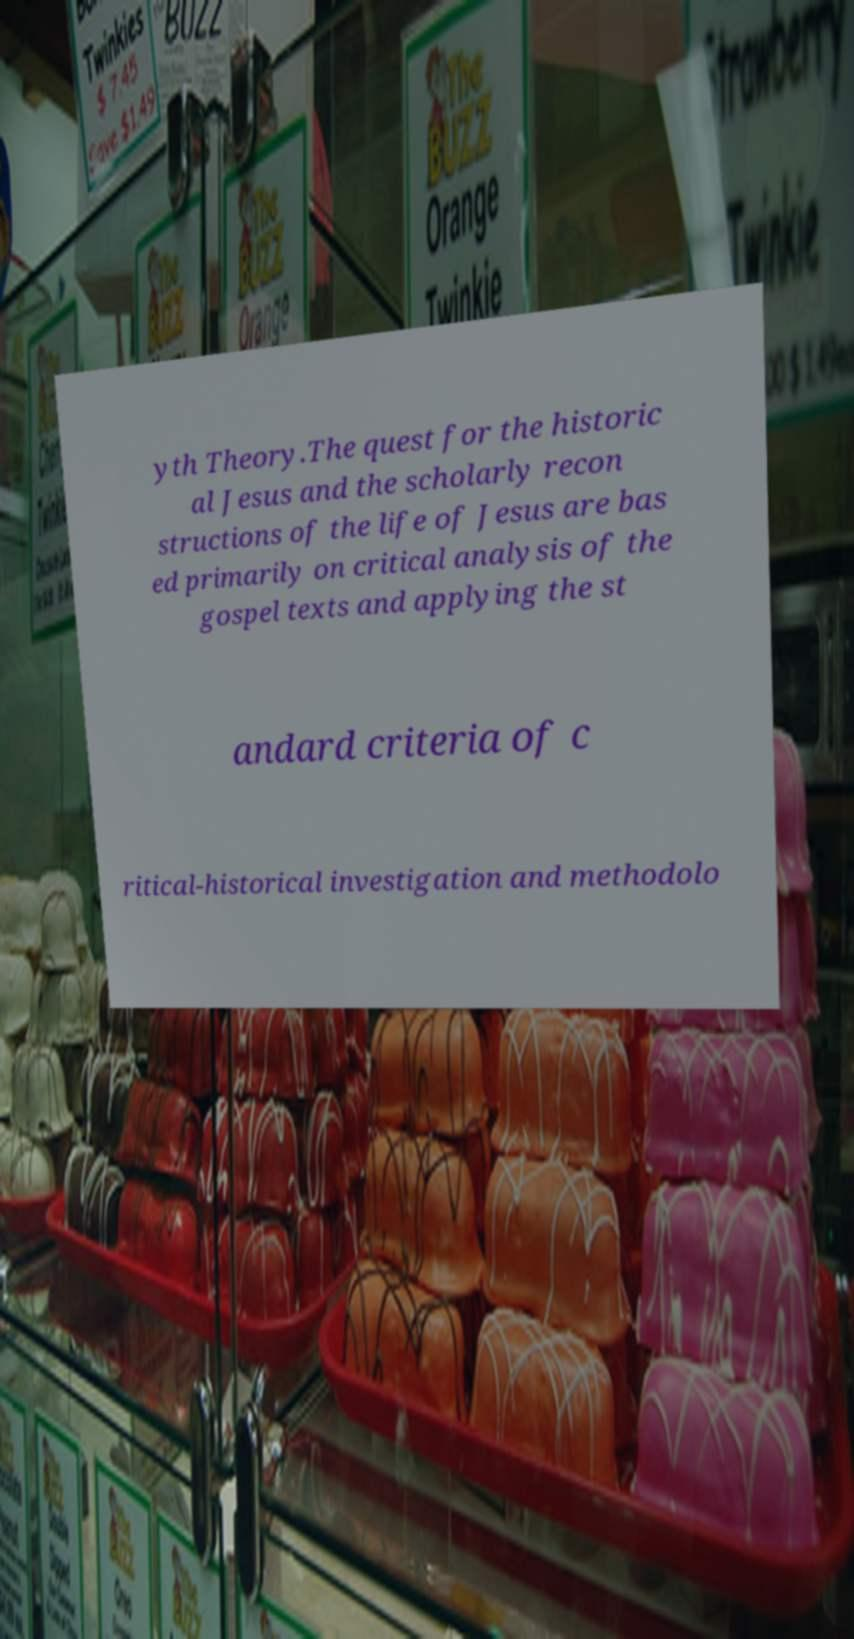Could you extract and type out the text from this image? yth Theory.The quest for the historic al Jesus and the scholarly recon structions of the life of Jesus are bas ed primarily on critical analysis of the gospel texts and applying the st andard criteria of c ritical-historical investigation and methodolo 